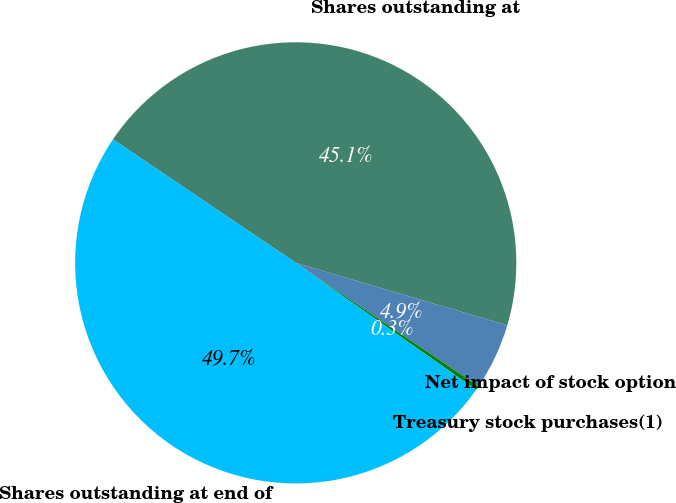<chart> <loc_0><loc_0><loc_500><loc_500><pie_chart><fcel>Shares outstanding at<fcel>Net impact of stock option<fcel>Treasury stock purchases(1)<fcel>Shares outstanding at end of<nl><fcel>45.11%<fcel>4.89%<fcel>0.3%<fcel>49.7%<nl></chart> 